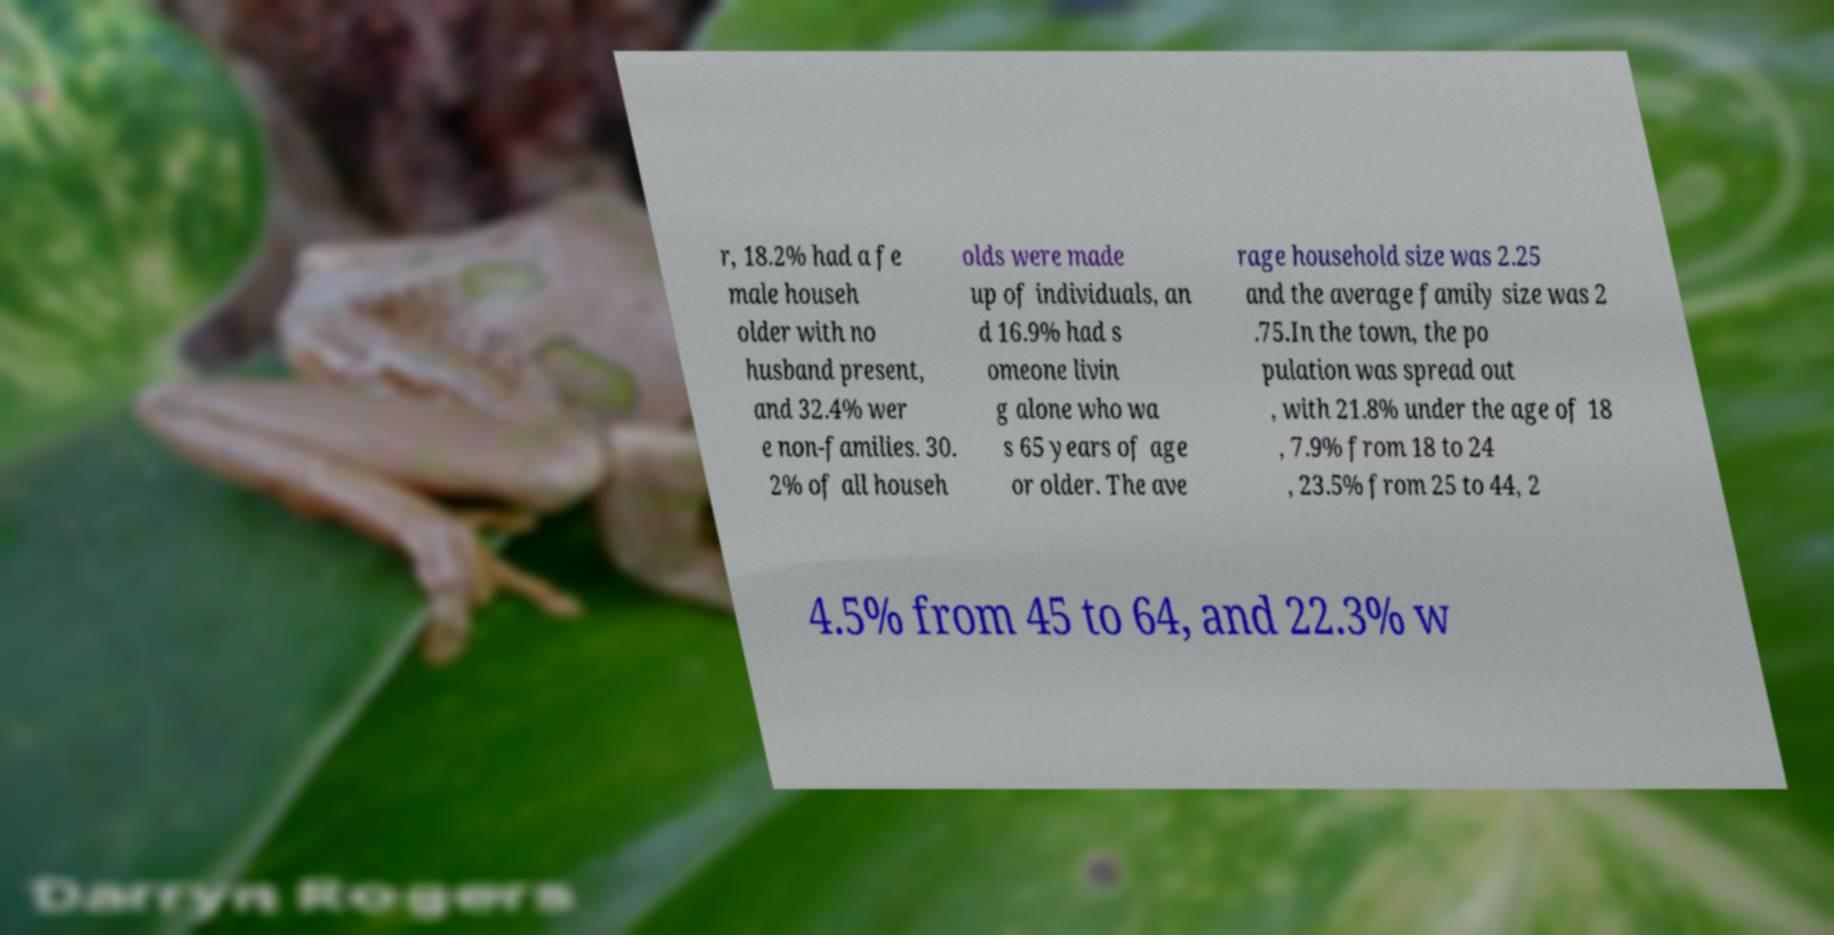Can you read and provide the text displayed in the image?This photo seems to have some interesting text. Can you extract and type it out for me? r, 18.2% had a fe male househ older with no husband present, and 32.4% wer e non-families. 30. 2% of all househ olds were made up of individuals, an d 16.9% had s omeone livin g alone who wa s 65 years of age or older. The ave rage household size was 2.25 and the average family size was 2 .75.In the town, the po pulation was spread out , with 21.8% under the age of 18 , 7.9% from 18 to 24 , 23.5% from 25 to 44, 2 4.5% from 45 to 64, and 22.3% w 